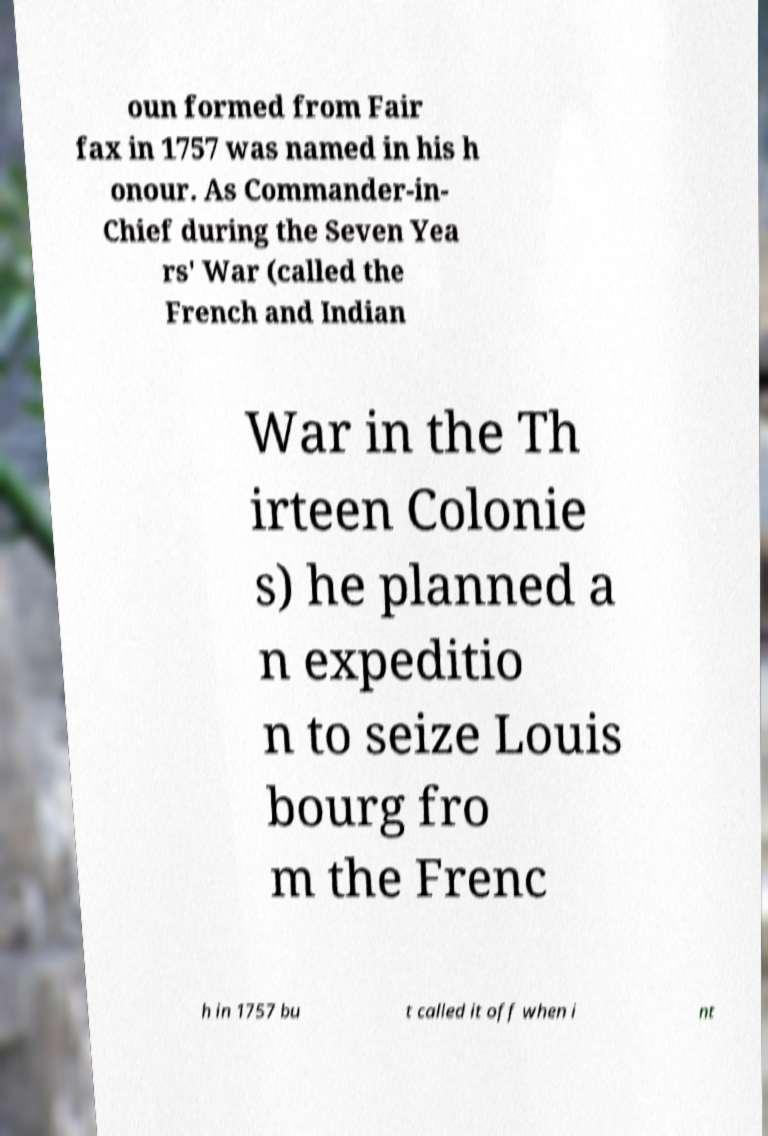Can you accurately transcribe the text from the provided image for me? oun formed from Fair fax in 1757 was named in his h onour. As Commander-in- Chief during the Seven Yea rs' War (called the French and Indian War in the Th irteen Colonie s) he planned a n expeditio n to seize Louis bourg fro m the Frenc h in 1757 bu t called it off when i nt 